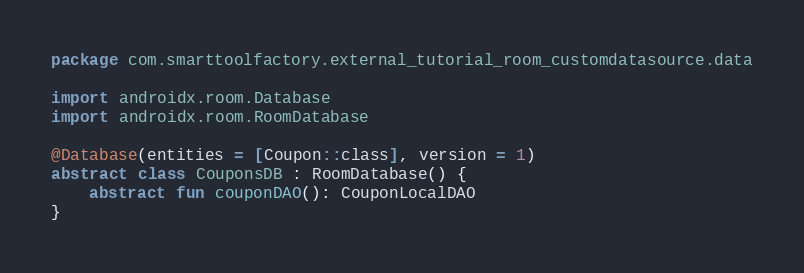Convert code to text. <code><loc_0><loc_0><loc_500><loc_500><_Kotlin_>package com.smarttoolfactory.external_tutorial_room_customdatasource.data

import androidx.room.Database
import androidx.room.RoomDatabase

@Database(entities = [Coupon::class], version = 1)
abstract class CouponsDB : RoomDatabase() {
    abstract fun couponDAO(): CouponLocalDAO
}</code> 